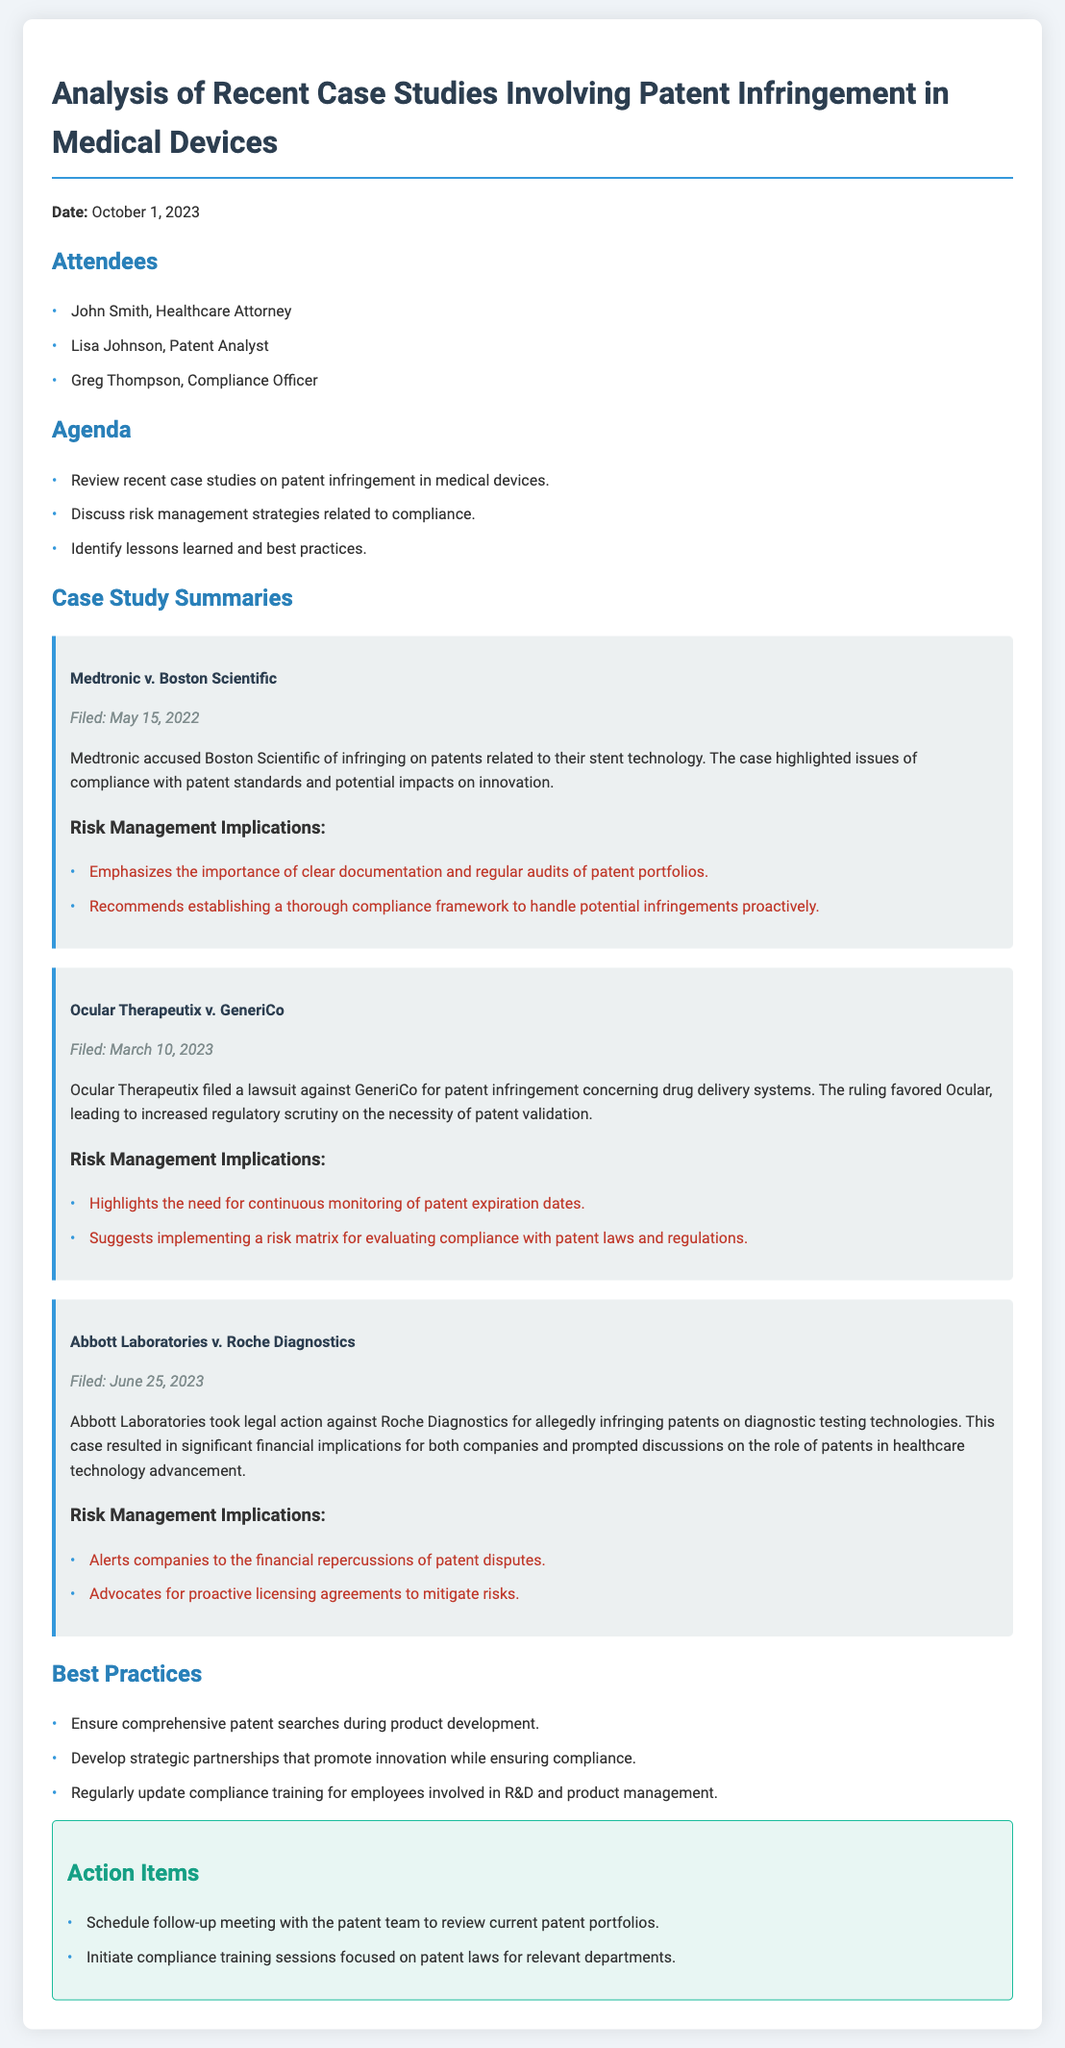What is the date of the meeting? The date of the meeting is provided in the header of the document.
Answer: October 1, 2023 Who is the Compliance Officer present in the meeting? The name of the Compliance Officer is listed under the attendees section.
Answer: Greg Thompson What was the first case study discussed? The first case study is mentioned at the beginning of the case study summaries section.
Answer: Medtronic v. Boston Scientific What key recommendation is made for risk management in the Medtronic case? The implications section under the Medtronic case study provides specific recommendations.
Answer: Clear documentation and regular audits How does the ruling in the Ocular Therapeutix case affect patent validation? The implications provide insights into the broader consequences of the ruling.
Answer: Increased regulatory scrutiny What is one of the best practices listed in the document? The best practices are outlined in a specific section towards the end of the document.
Answer: Comprehensive patent searches during product development How many action items were recorded in the meeting? The action items are listed in a dedicated section, and the quantity can be counted.
Answer: 2 When was the Abbott Laboratories case filed? The filing date is mentioned in the case study summary for Abbott Laboratories.
Answer: June 25, 2023 What type of legal action was taken in the Abbott Laboratories case? The type of legal action is described in the summary of the case study.
Answer: Infringement of patents 